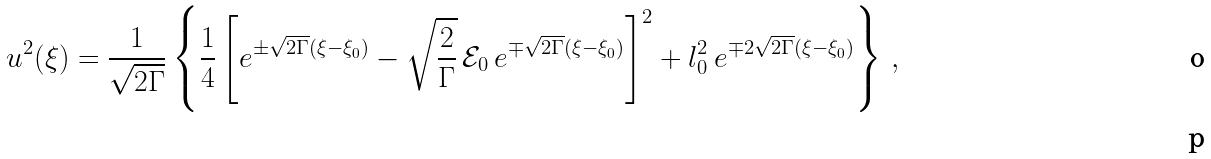<formula> <loc_0><loc_0><loc_500><loc_500>u ^ { 2 } ( \xi ) = \frac { 1 } { \sqrt { 2 \Gamma } } \left \{ \frac { 1 } { 4 } \left [ e ^ { \pm \sqrt { 2 \Gamma } ( \xi - \xi _ { 0 } ) } - \sqrt { \frac { 2 } { \Gamma } } \, \mathcal { E } _ { 0 } \, e ^ { \mp \sqrt { 2 \Gamma } ( \xi - \xi _ { 0 } ) } \right ] ^ { 2 } + l _ { 0 } ^ { 2 } \, e ^ { \mp 2 \sqrt { 2 \Gamma } ( \xi - \xi _ { 0 } ) } \right \} \, , \\</formula> 